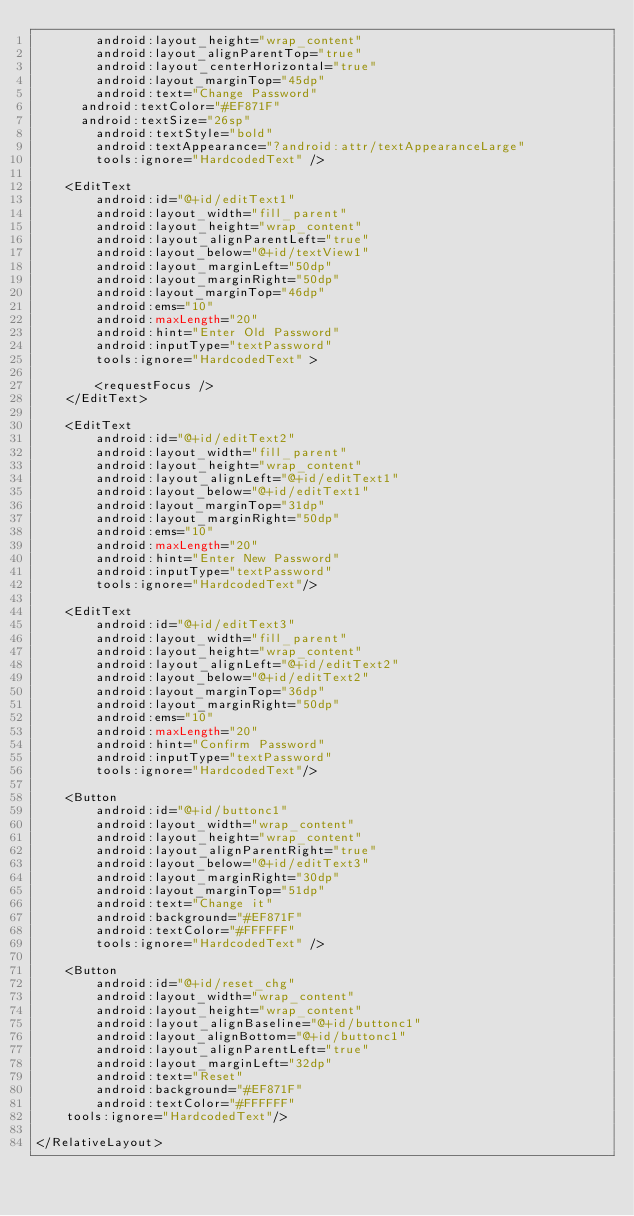Convert code to text. <code><loc_0><loc_0><loc_500><loc_500><_XML_>        android:layout_height="wrap_content"
        android:layout_alignParentTop="true"
        android:layout_centerHorizontal="true"
        android:layout_marginTop="45dp"
        android:text="Change Password"
 	    android:textColor="#EF871F"
 	    android:textSize="26sp"
        android:textStyle="bold"
        android:textAppearance="?android:attr/textAppearanceLarge"
        tools:ignore="HardcodedText" />

    <EditText
        android:id="@+id/editText1"
        android:layout_width="fill_parent"
        android:layout_height="wrap_content"
        android:layout_alignParentLeft="true"
        android:layout_below="@+id/textView1"
        android:layout_marginLeft="50dp"
        android:layout_marginRight="50dp"
        android:layout_marginTop="46dp"
        android:ems="10"
        android:maxLength="20"
        android:hint="Enter Old Password"
        android:inputType="textPassword"
        tools:ignore="HardcodedText" >

        <requestFocus />
    </EditText>

    <EditText
        android:id="@+id/editText2"
        android:layout_width="fill_parent"
        android:layout_height="wrap_content"
        android:layout_alignLeft="@+id/editText1"
        android:layout_below="@+id/editText1"
        android:layout_marginTop="31dp"
        android:layout_marginRight="50dp"
        android:ems="10"
        android:maxLength="20"
        android:hint="Enter New Password"
        android:inputType="textPassword" 
        tools:ignore="HardcodedText"/>

    <EditText
        android:id="@+id/editText3"
        android:layout_width="fill_parent"
        android:layout_height="wrap_content"
        android:layout_alignLeft="@+id/editText2"
        android:layout_below="@+id/editText2"
        android:layout_marginTop="36dp"
        android:layout_marginRight="50dp"
        android:ems="10"
        android:maxLength="20"
        android:hint="Confirm Password"
        android:inputType="textPassword" 
        tools:ignore="HardcodedText"/>

    <Button
        android:id="@+id/buttonc1"
        android:layout_width="wrap_content"
        android:layout_height="wrap_content"
        android:layout_alignParentRight="true"
        android:layout_below="@+id/editText3"
        android:layout_marginRight="30dp"
        android:layout_marginTop="51dp"
        android:text="Change it"
        android:background="#EF871F"
        android:textColor="#FFFFFF"
        tools:ignore="HardcodedText" />

    <Button
        android:id="@+id/reset_chg"
        android:layout_width="wrap_content"
        android:layout_height="wrap_content"
        android:layout_alignBaseline="@+id/buttonc1"
        android:layout_alignBottom="@+id/buttonc1"
        android:layout_alignParentLeft="true"
        android:layout_marginLeft="32dp"
        android:text="Reset"
        android:background="#EF871F"
        android:textColor="#FFFFFF"
		tools:ignore="HardcodedText"/>

</RelativeLayout></code> 